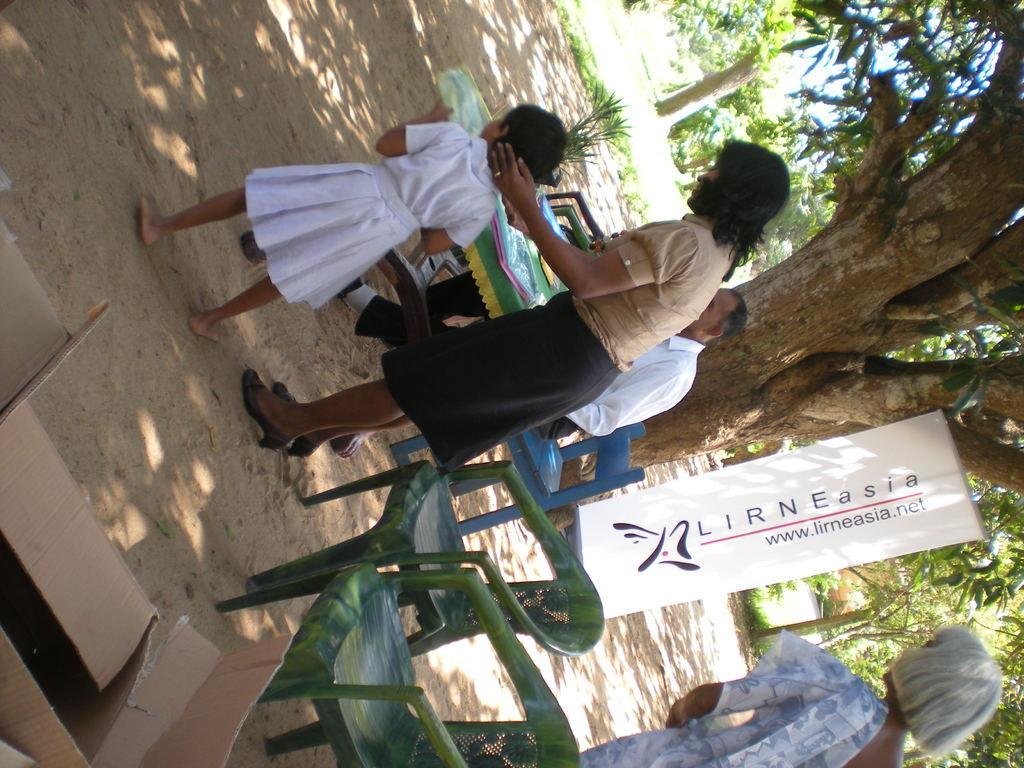In one or two sentences, can you explain what this image depicts? In this image there is a woman who is holding the kid who is standing on the ground. On the right side there are chairs. There is a person sitting in the chair. In front of him there is a table on which there are books,covers. At the bottom there is a cardboard box. In the background there is a tree. There is a banner attached to the tree. On the right side there is a woman on the floor. In the background there are trees. 